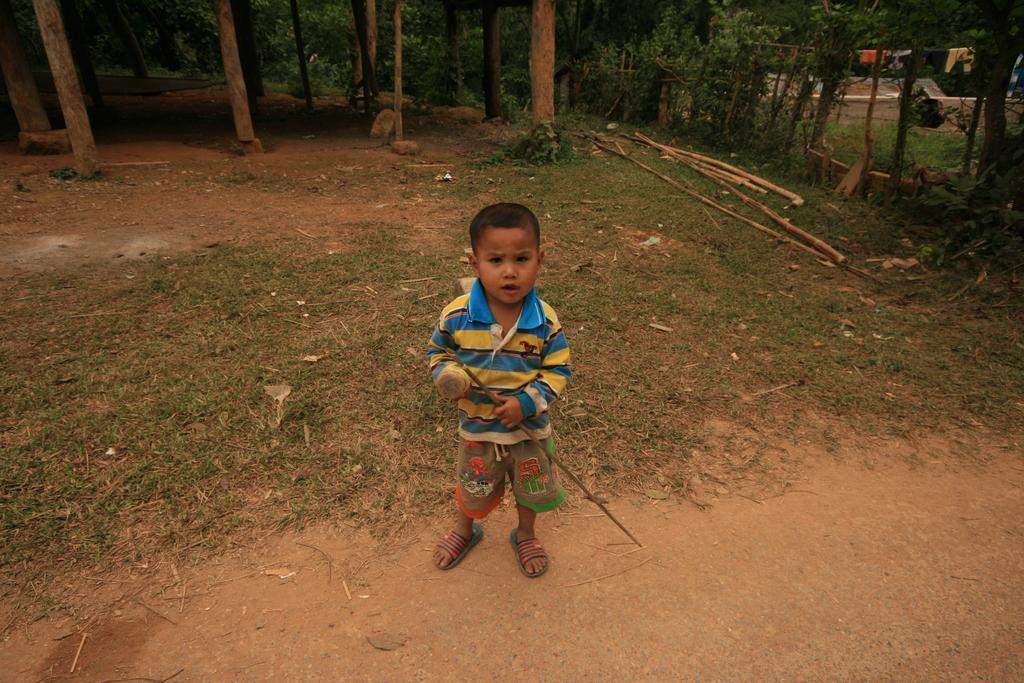Please provide a concise description of this image. In the center of the image, we can see a boy holding a stick and in the background, there are trees, poles, some logs and we can see clothes hanging on a rope. 